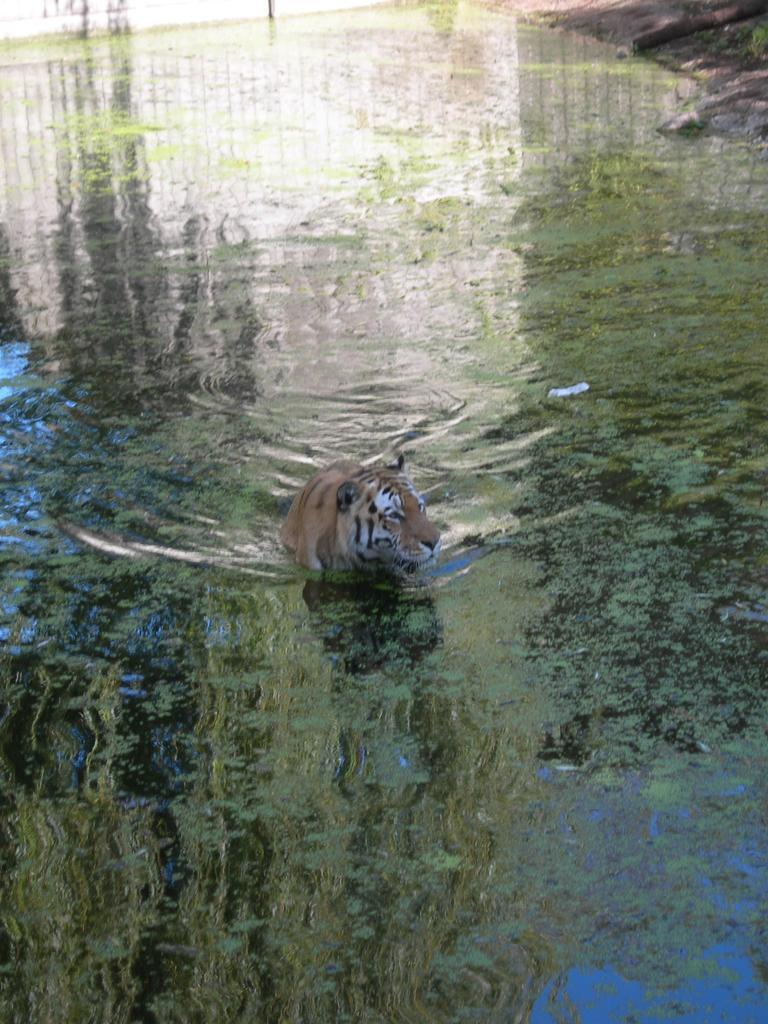What animal is in the image? There is a tiger in the image. Where is the tiger located? The tiger is in the water. What type of terrain is visible in the top right-hand corner of the image? There is land visible in the top right-hand corner of the image. What type of fowl can be seen wearing a vest in the image? There is no fowl or vest present in the image; it features a tiger in the water. What type of toys are visible in the image? There are no toys present in the image. 